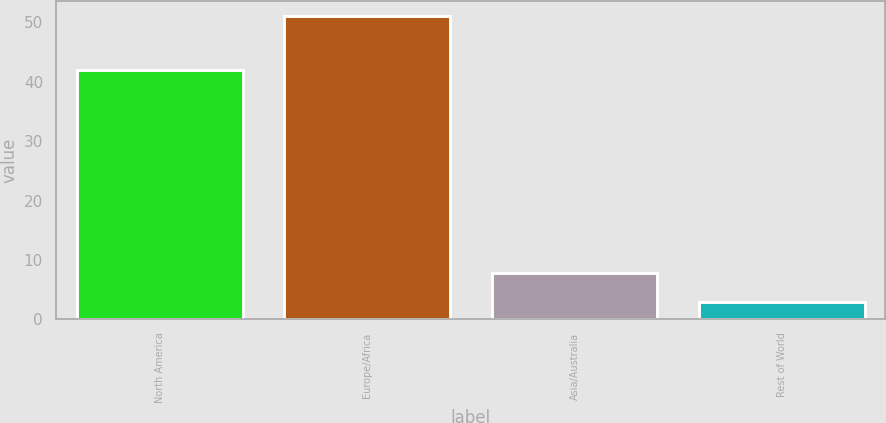<chart> <loc_0><loc_0><loc_500><loc_500><bar_chart><fcel>North America<fcel>Europe/Africa<fcel>Asia/Australia<fcel>Rest of World<nl><fcel>42<fcel>51<fcel>7.8<fcel>3<nl></chart> 